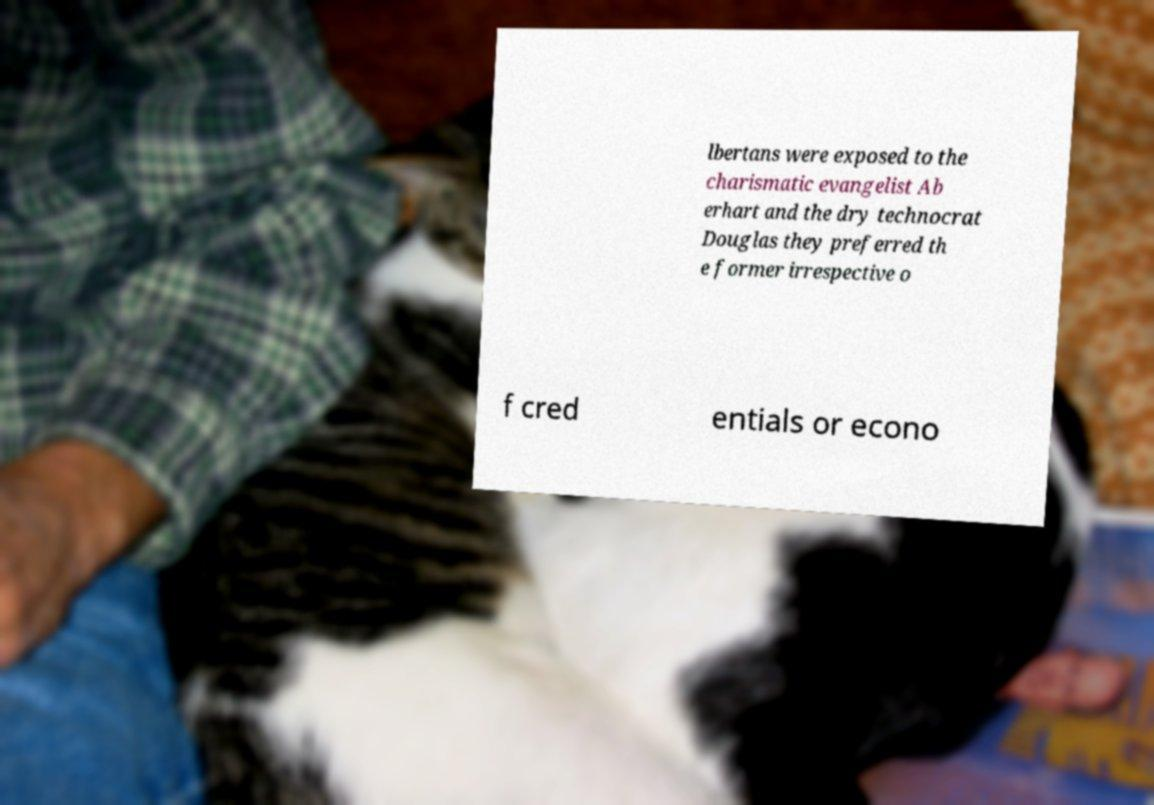For documentation purposes, I need the text within this image transcribed. Could you provide that? lbertans were exposed to the charismatic evangelist Ab erhart and the dry technocrat Douglas they preferred th e former irrespective o f cred entials or econo 